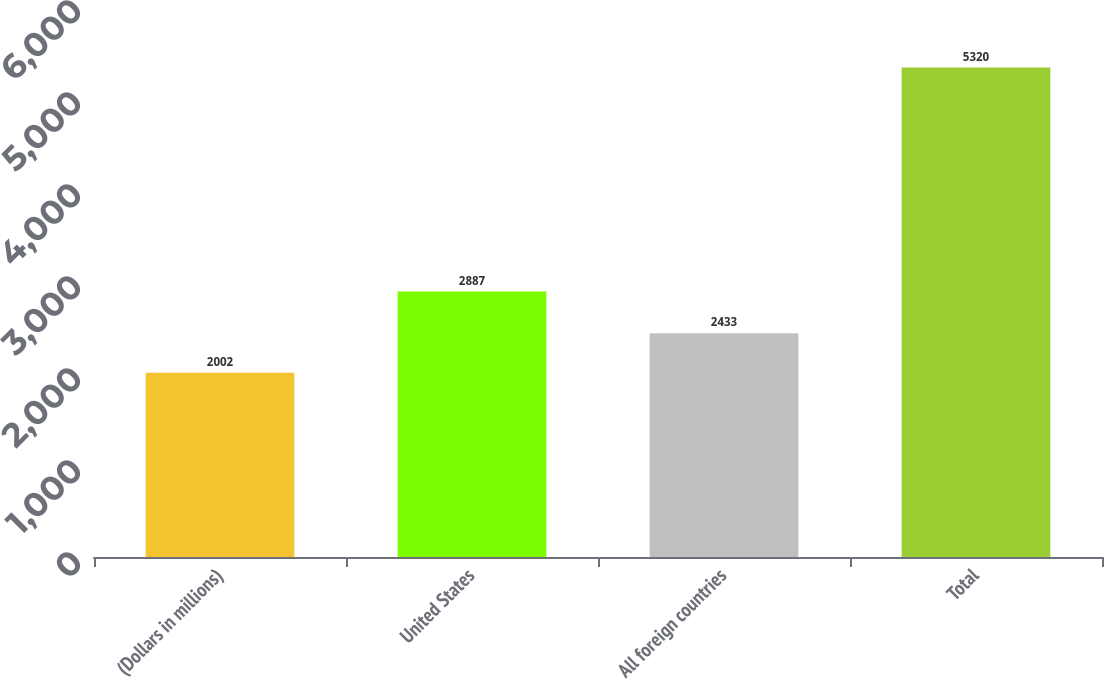Convert chart to OTSL. <chart><loc_0><loc_0><loc_500><loc_500><bar_chart><fcel>(Dollars in millions)<fcel>United States<fcel>All foreign countries<fcel>Total<nl><fcel>2002<fcel>2887<fcel>2433<fcel>5320<nl></chart> 